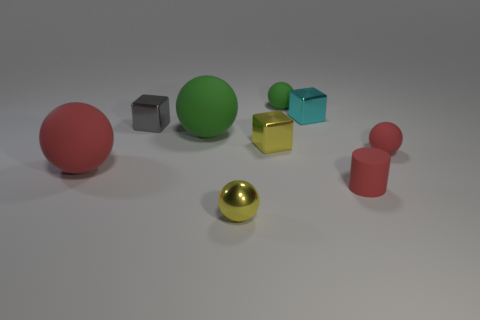How many other objects are the same color as the metallic sphere?
Make the answer very short. 1. There is a tiny object that is the same color as the metal ball; what material is it?
Your answer should be compact. Metal. How many objects are either large balls or tiny red objects?
Make the answer very short. 4. Are the big ball left of the big green matte sphere and the small gray object made of the same material?
Offer a terse response. No. How many things are either tiny red rubber things that are on the right side of the rubber cylinder or small yellow shiny spheres?
Provide a succinct answer. 2. What color is the cylinder that is made of the same material as the tiny green thing?
Provide a succinct answer. Red. Is there another shiny cube that has the same size as the cyan block?
Your answer should be very brief. Yes. There is a large matte thing that is on the left side of the gray shiny object; is it the same color as the tiny shiny ball?
Your answer should be compact. No. There is a rubber sphere that is both on the right side of the tiny gray thing and in front of the big green object; what color is it?
Your answer should be compact. Red. What is the shape of the green rubber object that is the same size as the yellow metal sphere?
Make the answer very short. Sphere. 